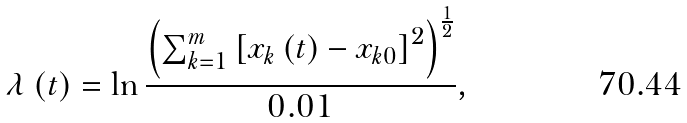Convert formula to latex. <formula><loc_0><loc_0><loc_500><loc_500>\lambda \left ( t \right ) = \ln \frac { \left ( \sum _ { k = 1 } ^ { m } \left [ x _ { k } \left ( t \right ) - x _ { k 0 } \right ] ^ { 2 } \right ) ^ { \frac { 1 } { 2 } } } { 0 . 0 1 } ,</formula> 